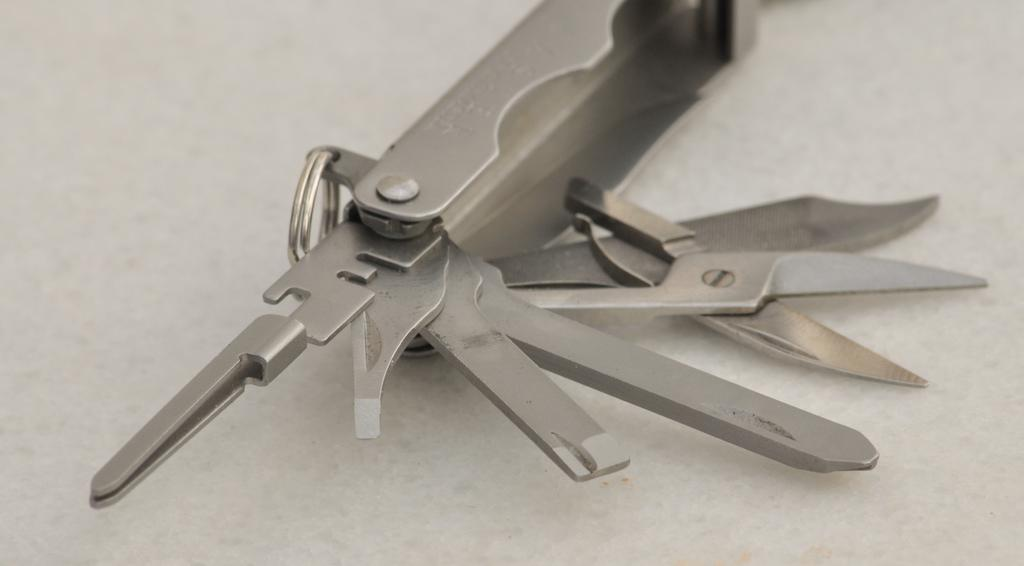What type of object is in the image? There is a metal tool in the image. What can be observed about the metal tool? The metal tool has different cutting items attached to it. Can you see a tiger using the metal tool in the image? There is no tiger present in the image, and the metal tool is not being used by any animal. What type of gardening tool is visible in the image? There is no gardening tool, such as a rake, present in the image. 